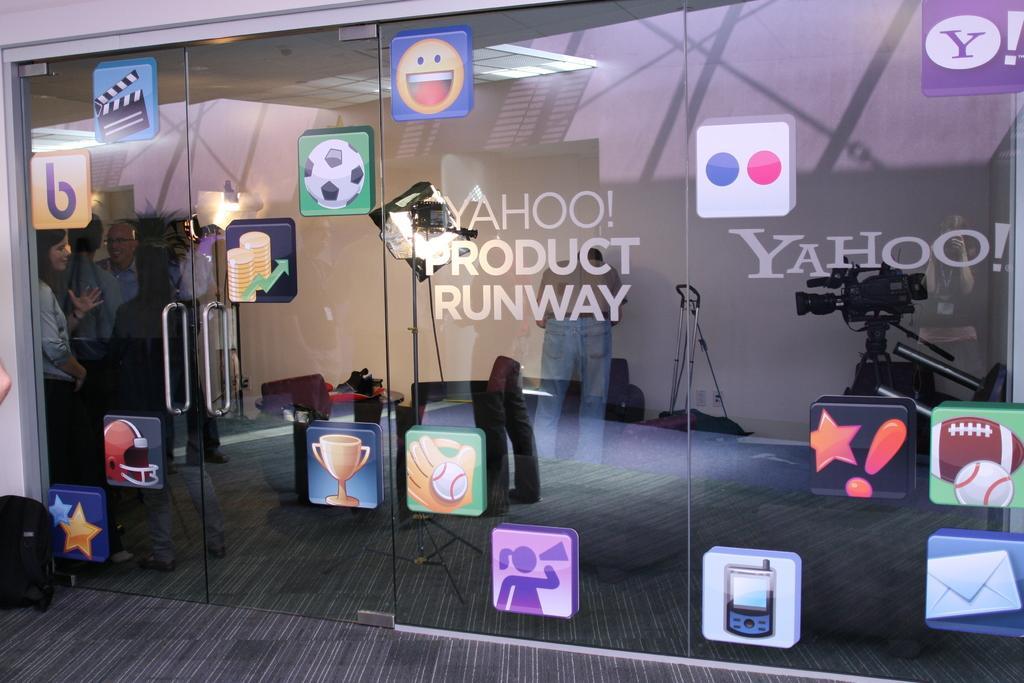Describe this image in one or two sentences. There is a room and on the doors of the room there are different logos attached,the doors are made up of glass and inside the room there are some people standing and discussing and in front of them there is a camera. 